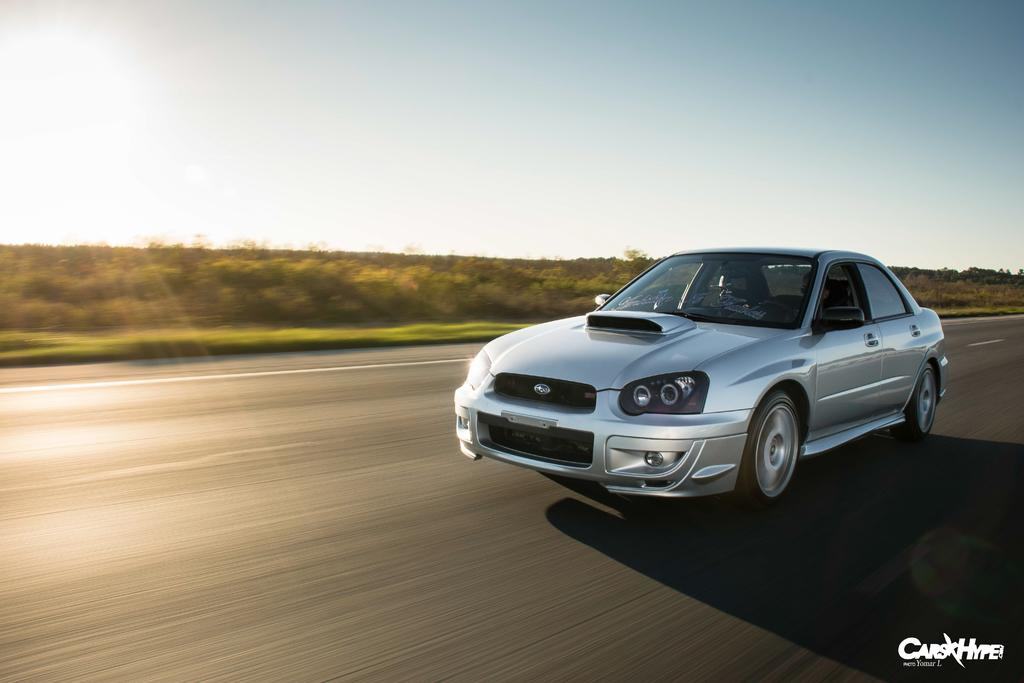What is the main subject of the image? There is a car on the road in the image. Is there any text present in the image? Yes, there is text written on the image. What type of vegetation can be seen at the side of the image? There are trees at the side of the image. What is visible at the top of the image? The sky is visible at the top of the image. How many farms can be seen in the image? There are no farms present in the image. Is there a flock of birds visible in the image? There is no flock of birds visible in the image. 